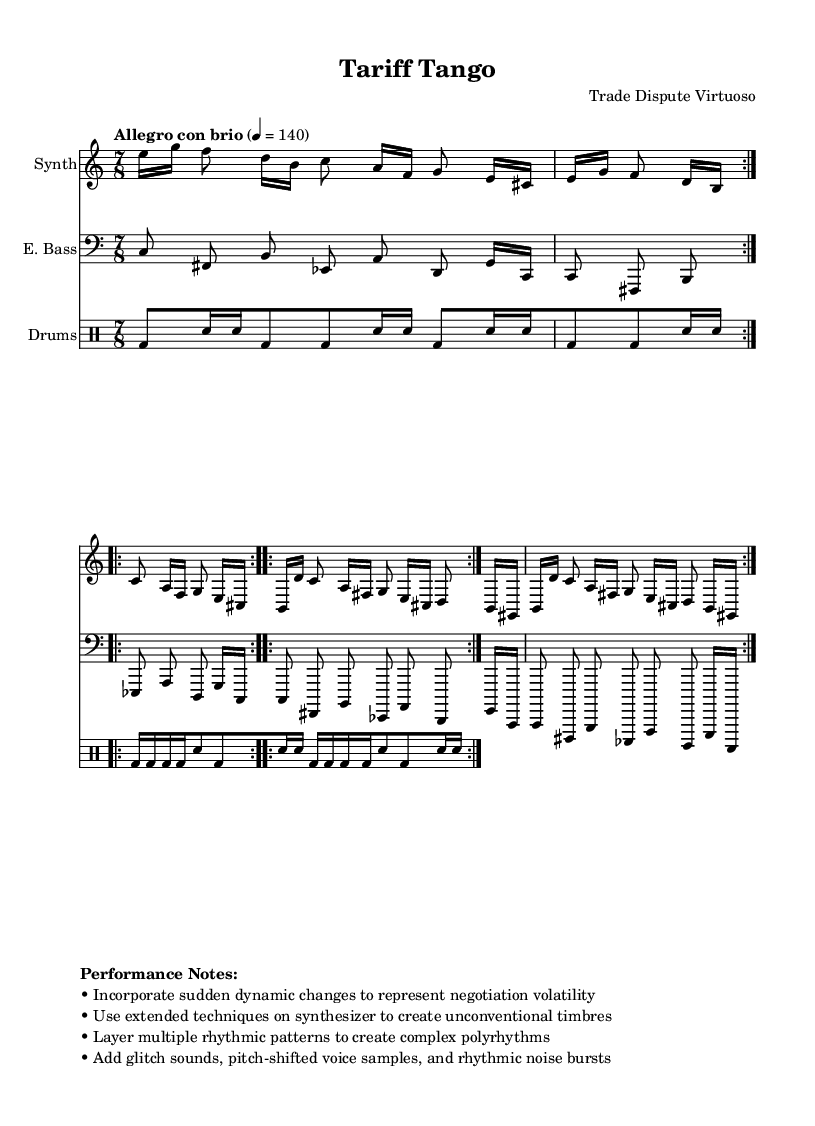What is the time signature of this composition? The time signature is indicated at the beginning of the score. It shows that the piece is in 7/8, which means there are seven beats in each measure and the eighth note gets one beat.
Answer: 7/8 What is the tempo marking? The tempo marking is located at the beginning of the score, indicating the pace of the piece. It states "Allegro con brio," followed by the metronome mark of 140, which means it should be played briskly and energetically at 140 beats per minute.
Answer: Allegro con brio, 140 How many volta sections are in the synthesizer part? In the synthesizer part, there are repeated sections indicated by "repeat volta" marks. The score shows that the synthesizer part has two volta sections repeated, confirming that each of these sections is played twice.
Answer: 2 What extended techniques are suggested for the synthesizer? The performance notes specifically mention the use of "extended techniques" on synthesizer to create unconventional timbres. This indicates that players should use unique methods beyond traditional playing styles to produce new sounds.
Answer: Extended techniques How does the drum machine enhance the composition's complexity? The drum machine utilizes multiple rhythmic patterns and variations, as demonstrated by the repeated volta sections with changing rhythms. This layering contributes to the overall complexity of the composition, aligning with the experimental nature of the piece.
Answer: Layering rhythmic patterns What kind of sound elements are encouraged in the performance notes? The performance notes explicitly recommend incorporating "glitch sounds, pitch-shifted voice samples, and rhythmic noise bursts" into the performance. These elements are characteristic of avant-garde styles and serve to enhance the experimental texture of the piece.
Answer: Glitch sounds, pitch-shifted voice samples 